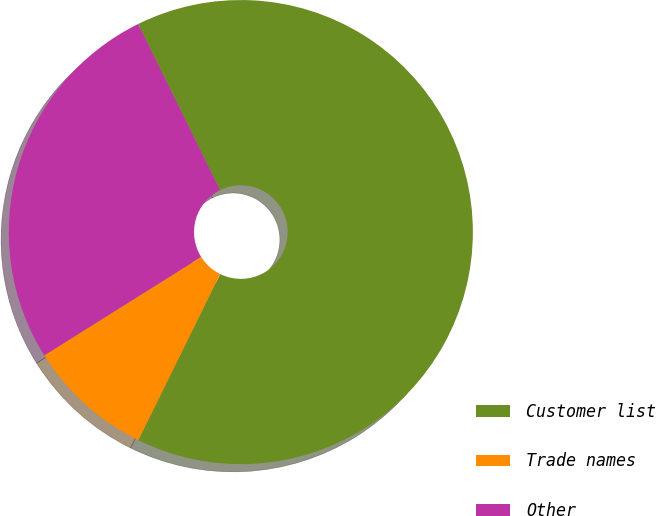Convert chart. <chart><loc_0><loc_0><loc_500><loc_500><pie_chart><fcel>Customer list<fcel>Trade names<fcel>Other<nl><fcel>64.58%<fcel>8.8%<fcel>26.62%<nl></chart> 